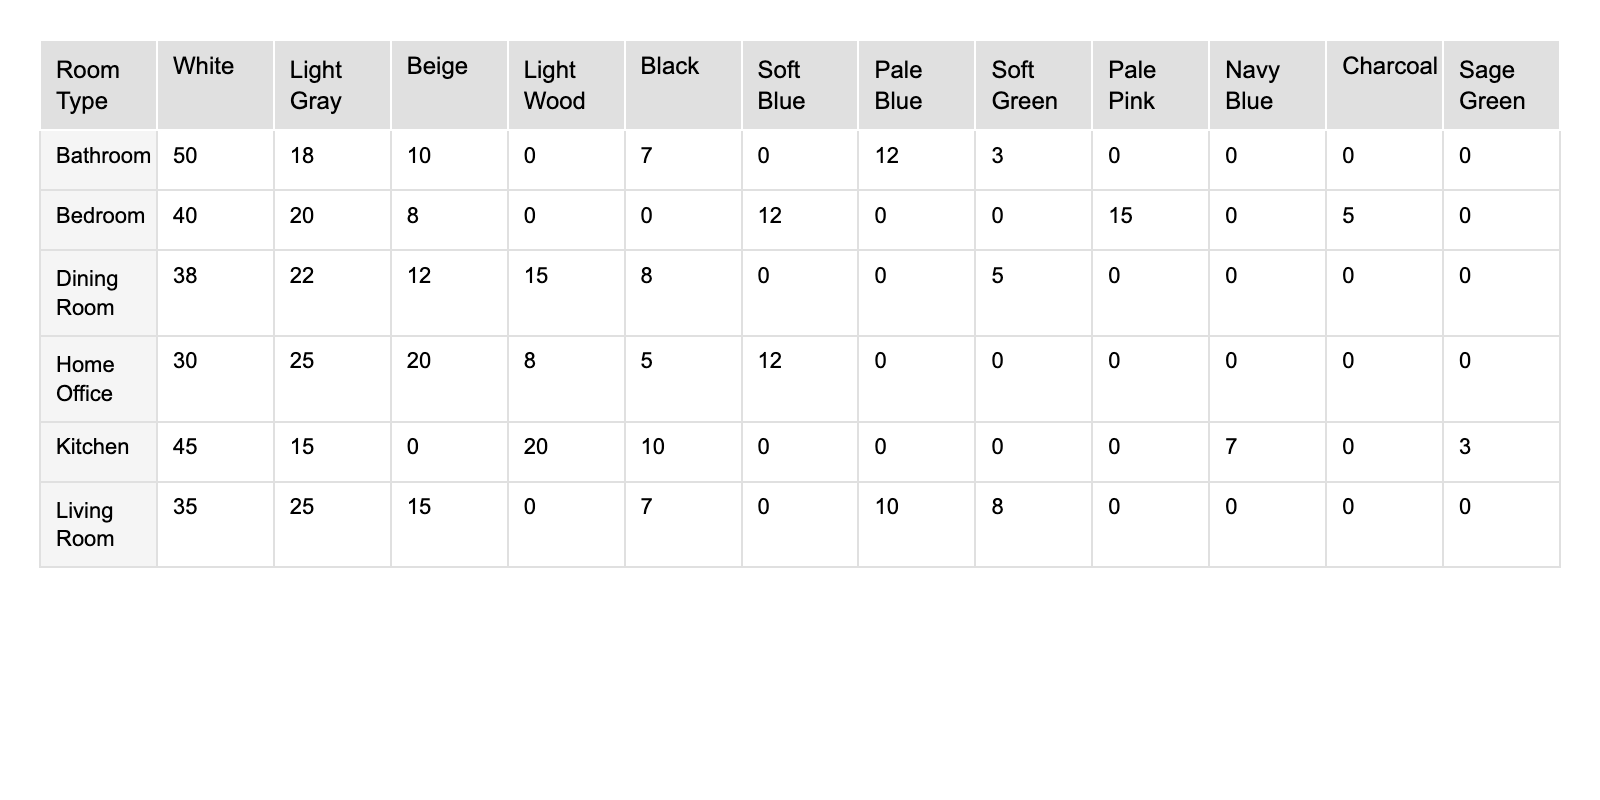What is the most preferred color in the Living Room? In the Living Room category, the color with the highest percentage is White at 35%.
Answer: White What percentage of the Bedroom preferences is for Soft Blue? In the Bedroom section, Soft Blue has a percentage of 12%. This value can be directly found in the table without any calculations.
Answer: 12% Which room type has the highest percentage of color preference for White? By analyzing the table, it's clear that the Bathroom has the highest percentage for White at 50%.
Answer: Bathroom What color is favored the least in the Kitchen? Looking at the Kitchen row, Sage Green has the lowest percentage at 3%. Thus, it is the least favored color in that category.
Answer: Sage Green What is the total percentage of color preferences for the Dining Room? The total percentage for the Dining Room can be calculated by adding the percentages of all colors listed: 38 + 22 + 15 + 12 + 8 + 5 = 100%. The total represents all responses combined for this room type.
Answer: 100% Is there a color that has the same percentage in any two room types? Yes, Light Gray appears in both the Living Room and Home Office with percentages of 25% and 25% respectively. This means Light Gray has the same preference across both categories.
Answer: Yes What is the average percentage preference for Black across all listed room types? The percentage for Black across the different room types are: 7 in Living Room, 5 in Bedroom, 10 in Kitchen, 7 in Bathroom, 5 in Home Office, and 8 in Dining Room. Adding these gives a total of 42. There are six room types, so the average is 42/6 = 7.
Answer: 7 Which room type has more diversity in color choice based on the number of different colors listed? The Kitchen has six unique color choices (White, Light Wood, Light Gray, Black, Navy Blue, Sage Green), which is more than any other room type. This indicates the most diversity in color options for that room type.
Answer: Kitchen What is the percentage difference in White color preferences between the Bathroom and the Living Room? The percentage of White in the Bathroom is 50%, and in the Living Room, it is 35%. The difference is calculated as 50 - 35 = 15%. This shows the level of preference for White in both contexts.
Answer: 15% 